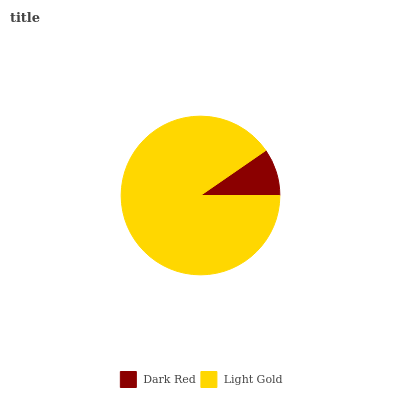Is Dark Red the minimum?
Answer yes or no. Yes. Is Light Gold the maximum?
Answer yes or no. Yes. Is Light Gold the minimum?
Answer yes or no. No. Is Light Gold greater than Dark Red?
Answer yes or no. Yes. Is Dark Red less than Light Gold?
Answer yes or no. Yes. Is Dark Red greater than Light Gold?
Answer yes or no. No. Is Light Gold less than Dark Red?
Answer yes or no. No. Is Light Gold the high median?
Answer yes or no. Yes. Is Dark Red the low median?
Answer yes or no. Yes. Is Dark Red the high median?
Answer yes or no. No. Is Light Gold the low median?
Answer yes or no. No. 